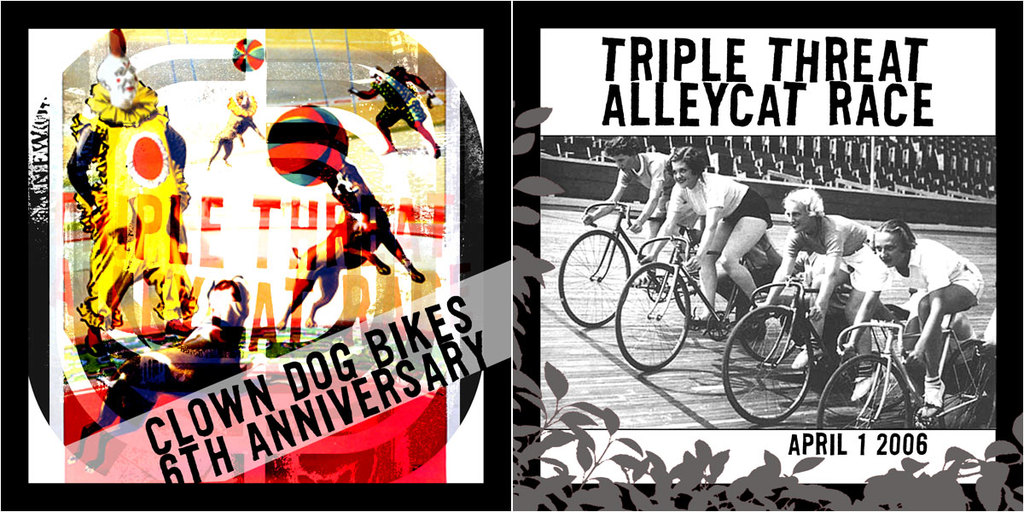Explain the historical significance of Alleycat races. Alleycat races started as informal bicycle races amongst urban cyclists, often messengers, navigating city streets and obstacles, offering a thrilling, grassroots style of competition that emphasizes speed, navigation skills, and local cycling culture.  How do these races impact the local community? Such races foster a robust sense of community and camaraderie among participants, while also bringing attention to urban cycling needs and safety. They also often involve local businesses and spectators, boosting community interaction and economic activity. 